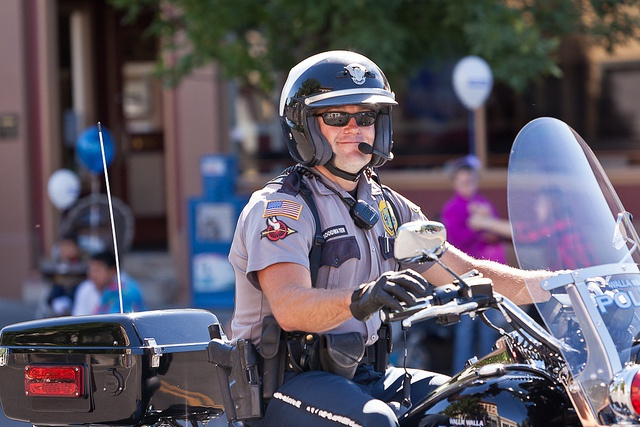Describe the objects in this image and their specific colors. I can see motorcycle in gray, black, and lavender tones, people in gray, black, darkgray, and navy tones, people in gray, violet, and darkgray tones, people in gray, black, and navy tones, and bicycle in gray and black tones in this image. 